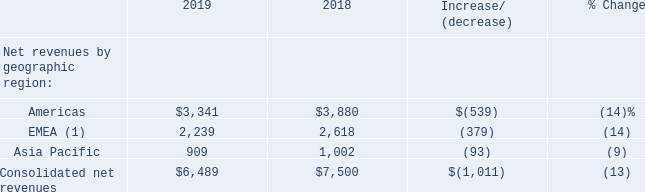Net Revenues by Geographic Region
The following table details our consolidated net revenues by geographic region (amounts in millions):
(1) “EMEA” consists of the Europe, Middle East, and Africa geographic regions
Americas
The decrease in net revenues in the Americas region for 2019, as compared to 2018, was primarily due to lower revenues recognized from the Destiny franchise (reflecting our sale of the publishing rights for Destiny to Bungie in December 2018).
EMEA
The decrease in net revenues in the EMEA region for 2019, as compared to 2018, was primarily due to:
lower revenues recognized from the Destiny franchise; and lower revenues recognized from Call of Duty: Black Ops 4, which was released in October 2018, as compared to Call of Duty: WWII, which was released in November 2017.
Asia Pacific
The decrease in net revenues in the Asia Pacific region for 2019, as compared to 2018, was primarily due to:
lower revenues recognized from Hearthstone, primarily due to the prior year including additional digital content delivered in connection with the renewal of our contract with NetEase, Inc. in December 2018, with no equivalent transaction for the franchise in 2019; and lower revenues recognized from the Destiny franchise.
The decrease was partially offset by:• revenues recognized from Crash Team Racing Nitro-Fueled, which was released in June 2019; • revenues from Sekiro: Shadows Die Twice, which was released in March 2019; and • higher revenues recognized from Call of Duty: Modern Warfare, which was released in October 2019, as compared to Call of Duty: Black Ops 4.
What does 'EMEA' consist of? The europe, middle east, and africa geographic regions. What was the primary reason for the decrease in net revenues in the Americas region for 2019 compared to 2018? Lower revenues recognized from the destiny franchise (reflecting our sale of the publishing rights for destiny to bungie in december 2018). What was the net revenue from Americas in 2019?
Answer scale should be: million. $3,341. What was the total net revenues in 2019 of Americas and EMEA?
Answer scale should be: million. ($3,341+2,239)
Answer: 5580. What was the total net revenues in 2018 of Americas and EMEA?
Answer scale should be: million. $3,880+2,618
Answer: 6498. What percentage of consolidated net revenue in 2019 consists of net revenue from Americas?
Answer scale should be: percent. ($3,341/$6,489)
Answer: 51.49. 